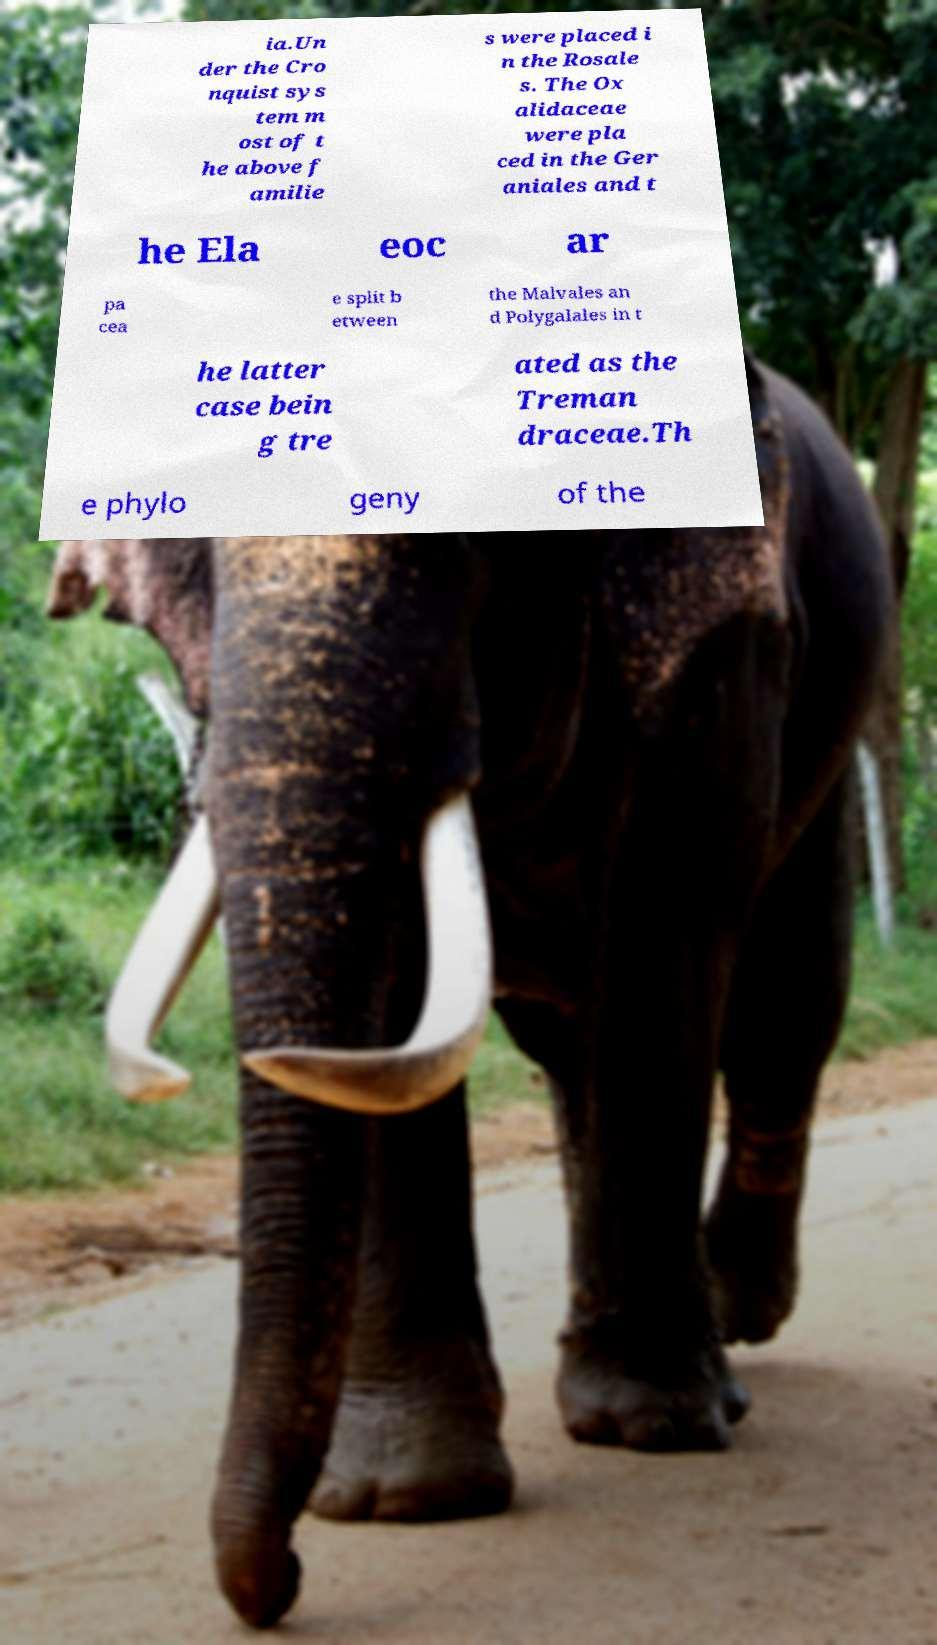I need the written content from this picture converted into text. Can you do that? ia.Un der the Cro nquist sys tem m ost of t he above f amilie s were placed i n the Rosale s. The Ox alidaceae were pla ced in the Ger aniales and t he Ela eoc ar pa cea e split b etween the Malvales an d Polygalales in t he latter case bein g tre ated as the Treman draceae.Th e phylo geny of the 